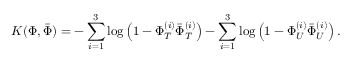Convert formula to latex. <formula><loc_0><loc_0><loc_500><loc_500>K ( \Phi , { \bar { \Phi } } ) = - \sum _ { i = 1 } ^ { 3 } \log \left ( 1 - \Phi _ { T } ^ { ( i ) } { \bar { \Phi } } _ { T } ^ { ( i ) } \right ) - \sum _ { i = 1 } ^ { 3 } \log \left ( 1 - \Phi _ { U } ^ { ( i ) } { \bar { \Phi } } _ { U } ^ { ( i ) } \right ) .</formula> 